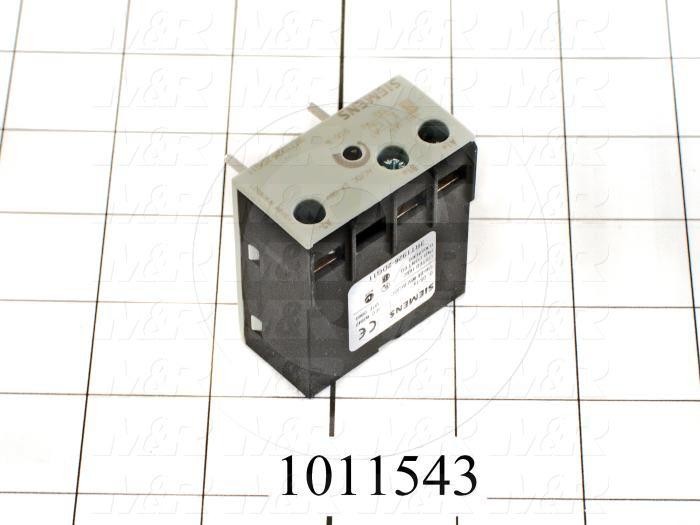What kind of maintenance does this component typically require? This electrical component would typically require periodic inspection and maintenance to ensure reliable performance. Maintenance tasks might include tightening the terminal screws to secure electrical connections, checking for signs of wear or damage such as cracks or corrosion on the casing, and verifying that the component is functioning correctly within its rated capacity. Furthermore, it may be necessary to clean the component and its surroundings to prevent dust accumulation, which could affect its performance. Ensuring that the component remains within a dry and temperature-controlled environment can also help extend its lifespan and maintain optimal functionality. 